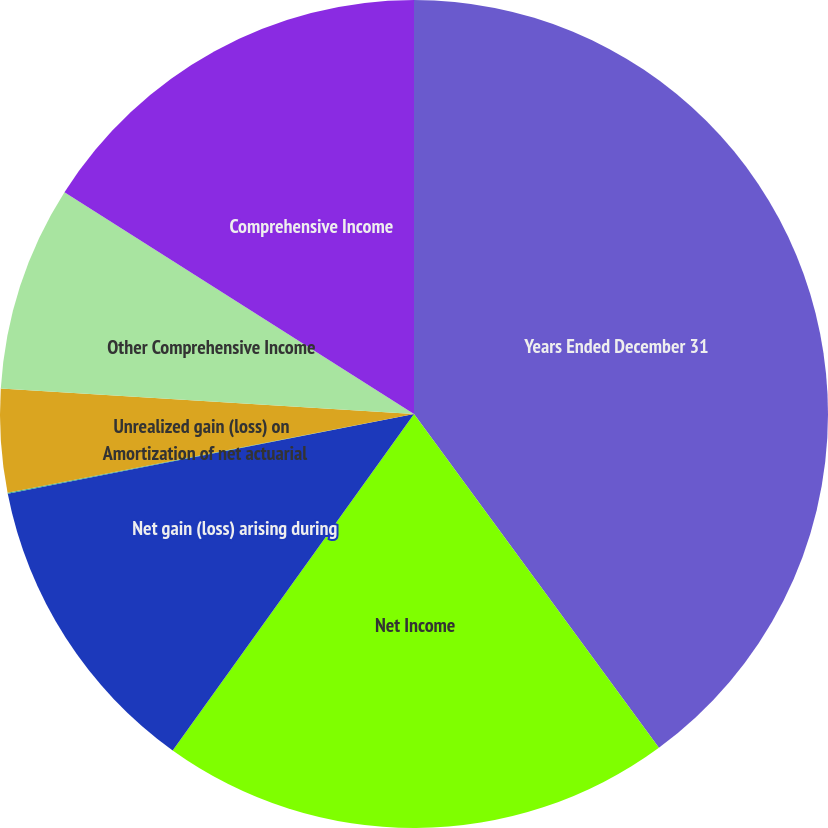Convert chart. <chart><loc_0><loc_0><loc_500><loc_500><pie_chart><fcel>Years Ended December 31<fcel>Net Income<fcel>Net gain (loss) arising during<fcel>Amortization of net actuarial<fcel>Unrealized gain (loss) on<fcel>Other Comprehensive Income<fcel>Comprehensive Income<nl><fcel>39.93%<fcel>19.98%<fcel>12.01%<fcel>0.04%<fcel>4.03%<fcel>8.02%<fcel>16.0%<nl></chart> 